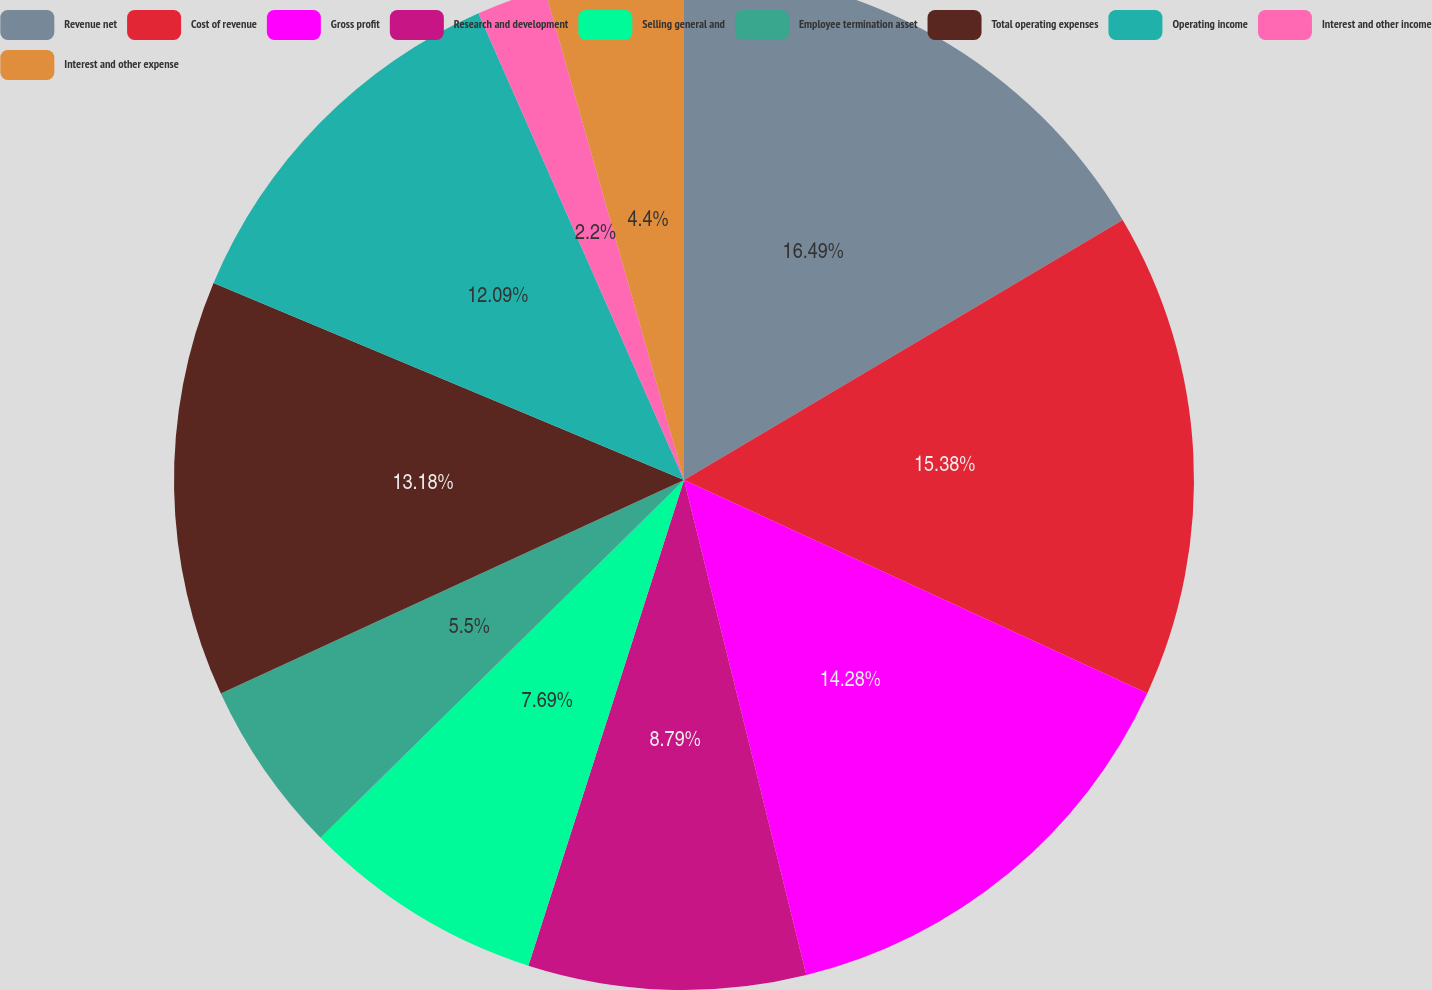Convert chart to OTSL. <chart><loc_0><loc_0><loc_500><loc_500><pie_chart><fcel>Revenue net<fcel>Cost of revenue<fcel>Gross profit<fcel>Research and development<fcel>Selling general and<fcel>Employee termination asset<fcel>Total operating expenses<fcel>Operating income<fcel>Interest and other income<fcel>Interest and other expense<nl><fcel>16.48%<fcel>15.38%<fcel>14.28%<fcel>8.79%<fcel>7.69%<fcel>5.5%<fcel>13.18%<fcel>12.09%<fcel>2.2%<fcel>4.4%<nl></chart> 